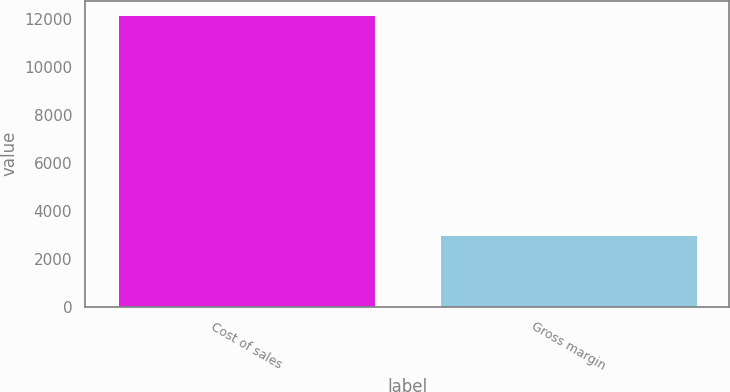Convert chart. <chart><loc_0><loc_0><loc_500><loc_500><bar_chart><fcel>Cost of sales<fcel>Gross margin<nl><fcel>12155<fcel>3010<nl></chart> 